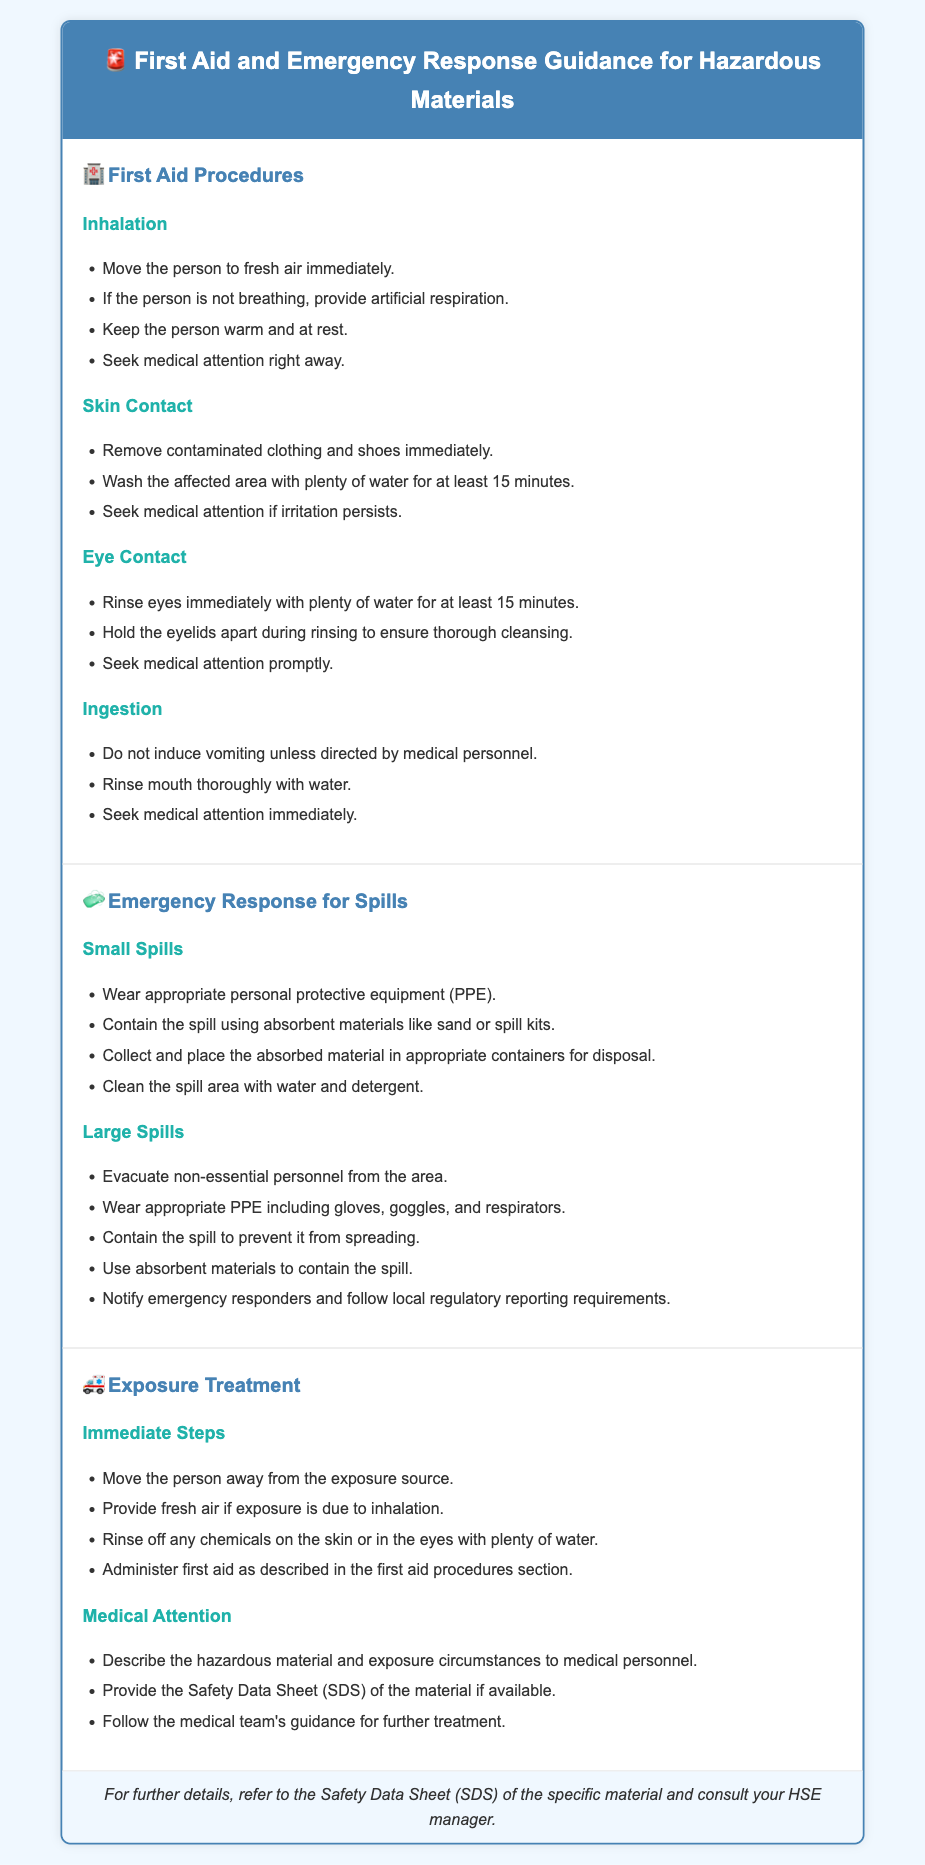What are the immediate steps for inhalation exposure? The immediate steps include moving the person to fresh air, providing artificial respiration if necessary, keeping them warm and at rest, and seeking medical attention.
Answer: Move to fresh air What should be done in case of skin contact? In case of skin contact, remove contaminated clothing, wash the affected area with plenty of water for at least 15 minutes, and seek medical attention if irritation persists.
Answer: Wash with water for 15 minutes How should small spills be managed? Small spills should involve wearing appropriate PPE, containing the spill with absorbent materials, collecting the absorbed material for disposal, and cleaning the area with water and detergent.
Answer: Wear PPE and contain with absorbent materials What is the first action for a large spill? The first action is to evacuate non-essential personnel from the area to ensure safety.
Answer: Evacuate non-essential personnel What documents should be provided to medical personnel? The Safety Data Sheet (SDS) of the material should be provided if available.
Answer: Safety Data Sheet (SDS) What is recommended for eye contact treatment? Eye contact treatment includes rinsing the eyes with plenty of water for at least 15 minutes, holding the eyelids apart during rinsing, and seeking medical attention.
Answer: Rinse with plenty of water for 15 minutes What type of protective equipment is necessary during a large spill response? Appropriate protective equipment (PPE) for a large spill includes gloves, goggles, and respirators.
Answer: Gloves, goggles, respirators What is the purpose of the footer in the document? The footer provides guidance for further details and recommendations to consult the HSE manager.
Answer: Consult your HSE manager 